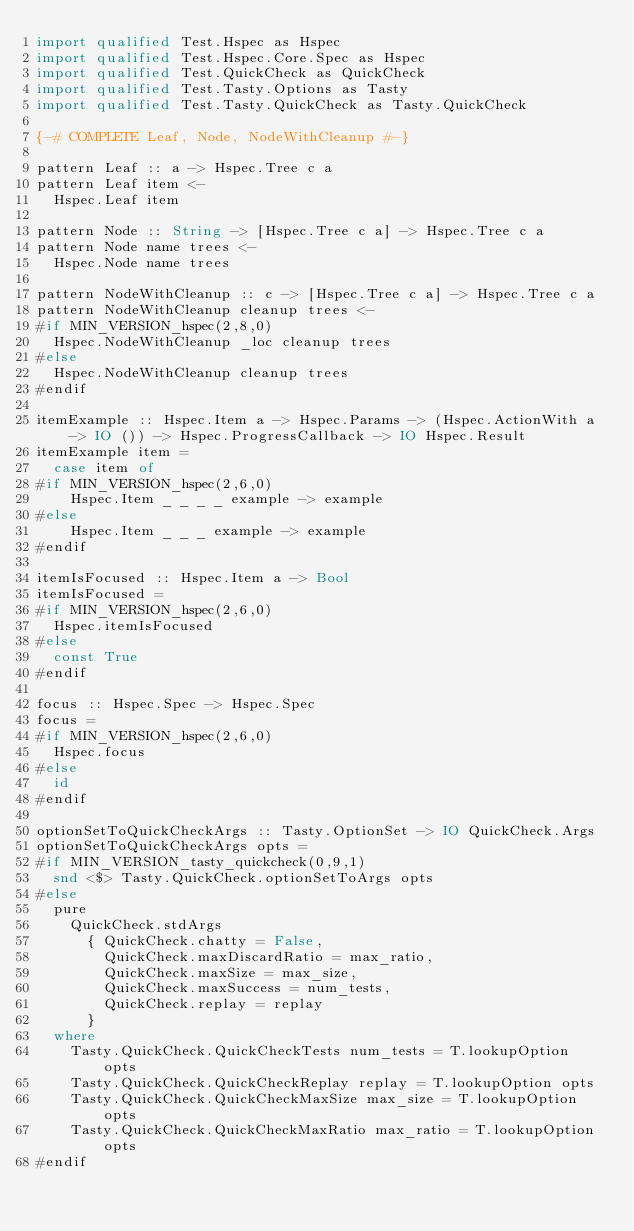Convert code to text. <code><loc_0><loc_0><loc_500><loc_500><_Haskell_>import qualified Test.Hspec as Hspec
import qualified Test.Hspec.Core.Spec as Hspec
import qualified Test.QuickCheck as QuickCheck
import qualified Test.Tasty.Options as Tasty
import qualified Test.Tasty.QuickCheck as Tasty.QuickCheck

{-# COMPLETE Leaf, Node, NodeWithCleanup #-}

pattern Leaf :: a -> Hspec.Tree c a
pattern Leaf item <-
  Hspec.Leaf item

pattern Node :: String -> [Hspec.Tree c a] -> Hspec.Tree c a
pattern Node name trees <-
  Hspec.Node name trees

pattern NodeWithCleanup :: c -> [Hspec.Tree c a] -> Hspec.Tree c a
pattern NodeWithCleanup cleanup trees <-
#if MIN_VERSION_hspec(2,8,0)
  Hspec.NodeWithCleanup _loc cleanup trees
#else
  Hspec.NodeWithCleanup cleanup trees
#endif

itemExample :: Hspec.Item a -> Hspec.Params -> (Hspec.ActionWith a -> IO ()) -> Hspec.ProgressCallback -> IO Hspec.Result
itemExample item =
  case item of
#if MIN_VERSION_hspec(2,6,0)
    Hspec.Item _ _ _ _ example -> example
#else
    Hspec.Item _ _ _ example -> example
#endif

itemIsFocused :: Hspec.Item a -> Bool
itemIsFocused =
#if MIN_VERSION_hspec(2,6,0)
  Hspec.itemIsFocused
#else
  const True
#endif

focus :: Hspec.Spec -> Hspec.Spec
focus =
#if MIN_VERSION_hspec(2,6,0)
  Hspec.focus
#else
  id
#endif

optionSetToQuickCheckArgs :: Tasty.OptionSet -> IO QuickCheck.Args
optionSetToQuickCheckArgs opts =
#if MIN_VERSION_tasty_quickcheck(0,9,1)
  snd <$> Tasty.QuickCheck.optionSetToArgs opts
#else
  pure
    QuickCheck.stdArgs
      { QuickCheck.chatty = False,
        QuickCheck.maxDiscardRatio = max_ratio,
        QuickCheck.maxSize = max_size,
        QuickCheck.maxSuccess = num_tests,
        QuickCheck.replay = replay
      }
  where
    Tasty.QuickCheck.QuickCheckTests num_tests = T.lookupOption opts
    Tasty.QuickCheck.QuickCheckReplay replay = T.lookupOption opts
    Tasty.QuickCheck.QuickCheckMaxSize max_size = T.lookupOption opts
    Tasty.QuickCheck.QuickCheckMaxRatio max_ratio = T.lookupOption opts
#endif

</code> 